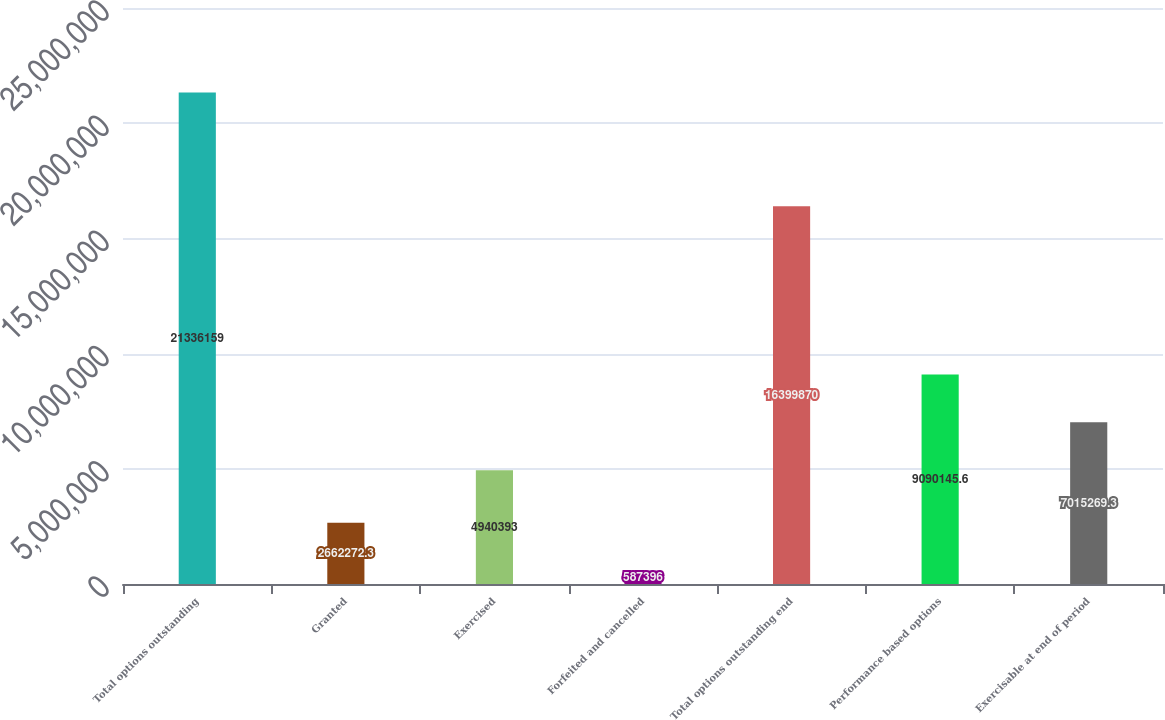Convert chart. <chart><loc_0><loc_0><loc_500><loc_500><bar_chart><fcel>Total options outstanding<fcel>Granted<fcel>Exercised<fcel>Forfeited and cancelled<fcel>Total options outstanding end<fcel>Performance based options<fcel>Exercisable at end of period<nl><fcel>2.13362e+07<fcel>2.66227e+06<fcel>4.94039e+06<fcel>587396<fcel>1.63999e+07<fcel>9.09015e+06<fcel>7.01527e+06<nl></chart> 